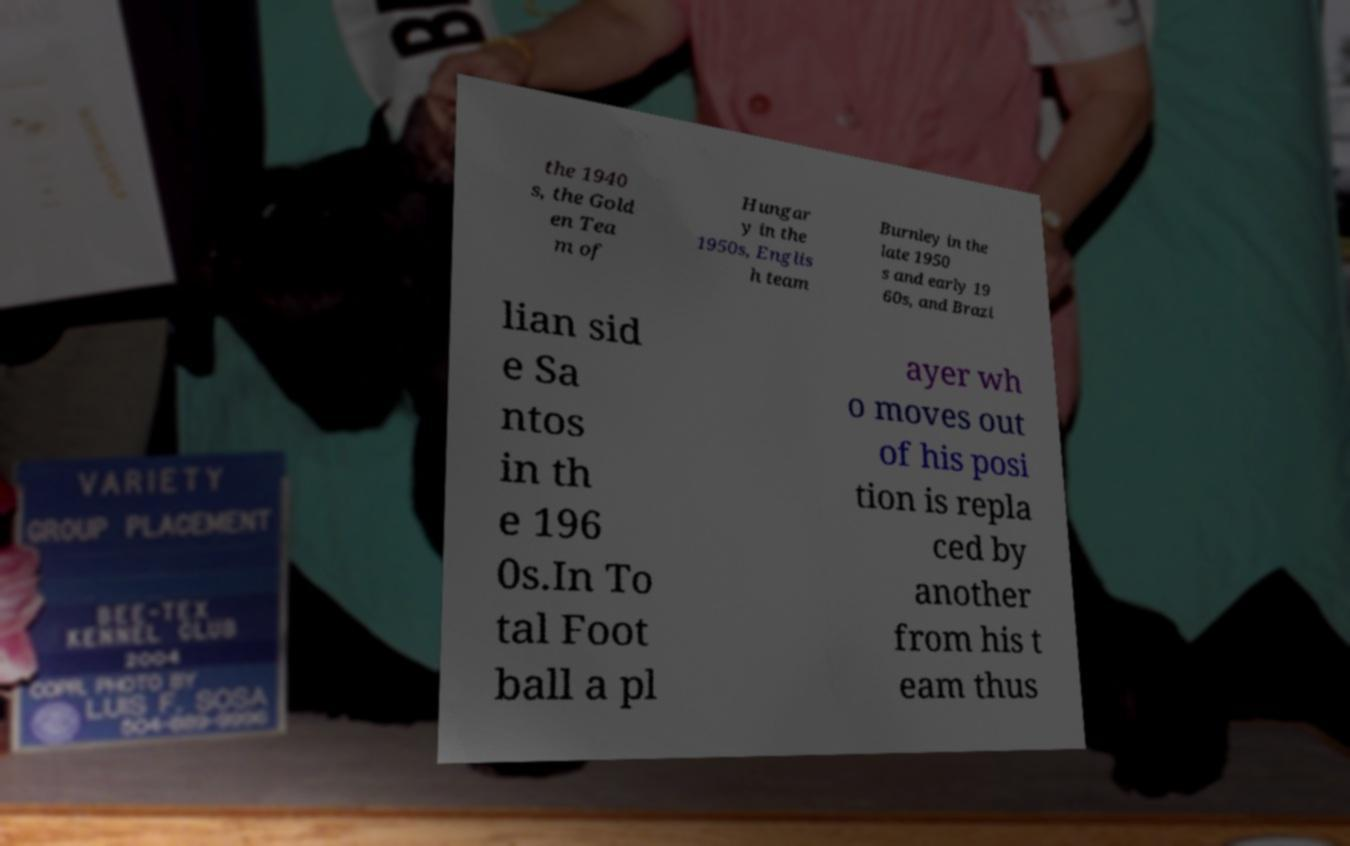Please read and relay the text visible in this image. What does it say? the 1940 s, the Gold en Tea m of Hungar y in the 1950s, Englis h team Burnley in the late 1950 s and early 19 60s, and Brazi lian sid e Sa ntos in th e 196 0s.In To tal Foot ball a pl ayer wh o moves out of his posi tion is repla ced by another from his t eam thus 